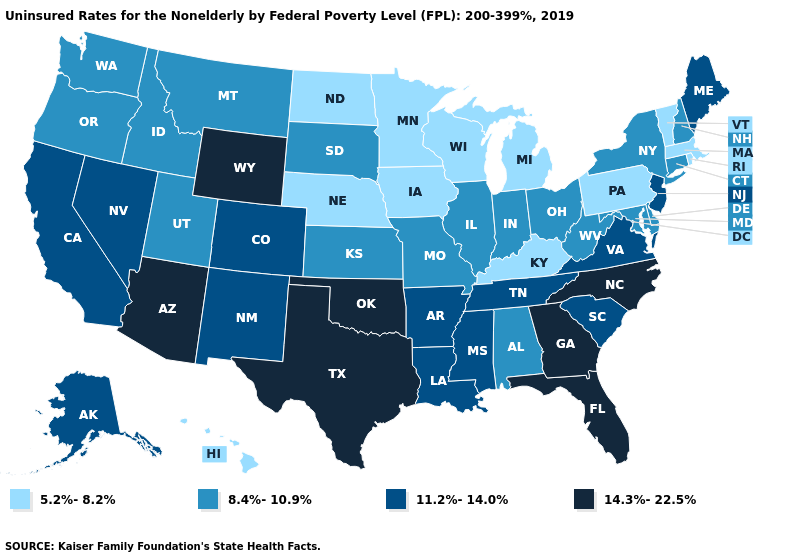Does California have the same value as Mississippi?
Concise answer only. Yes. What is the value of Utah?
Write a very short answer. 8.4%-10.9%. Name the states that have a value in the range 8.4%-10.9%?
Quick response, please. Alabama, Connecticut, Delaware, Idaho, Illinois, Indiana, Kansas, Maryland, Missouri, Montana, New Hampshire, New York, Ohio, Oregon, South Dakota, Utah, Washington, West Virginia. Is the legend a continuous bar?
Keep it brief. No. What is the value of Montana?
Short answer required. 8.4%-10.9%. What is the value of Missouri?
Give a very brief answer. 8.4%-10.9%. What is the value of Oklahoma?
Be succinct. 14.3%-22.5%. Which states have the lowest value in the USA?
Write a very short answer. Hawaii, Iowa, Kentucky, Massachusetts, Michigan, Minnesota, Nebraska, North Dakota, Pennsylvania, Rhode Island, Vermont, Wisconsin. Does North Carolina have the highest value in the USA?
Answer briefly. Yes. How many symbols are there in the legend?
Answer briefly. 4. Name the states that have a value in the range 5.2%-8.2%?
Keep it brief. Hawaii, Iowa, Kentucky, Massachusetts, Michigan, Minnesota, Nebraska, North Dakota, Pennsylvania, Rhode Island, Vermont, Wisconsin. Name the states that have a value in the range 8.4%-10.9%?
Concise answer only. Alabama, Connecticut, Delaware, Idaho, Illinois, Indiana, Kansas, Maryland, Missouri, Montana, New Hampshire, New York, Ohio, Oregon, South Dakota, Utah, Washington, West Virginia. Among the states that border North Carolina , which have the lowest value?
Short answer required. South Carolina, Tennessee, Virginia. Does the first symbol in the legend represent the smallest category?
Keep it brief. Yes. What is the lowest value in the USA?
Be succinct. 5.2%-8.2%. 